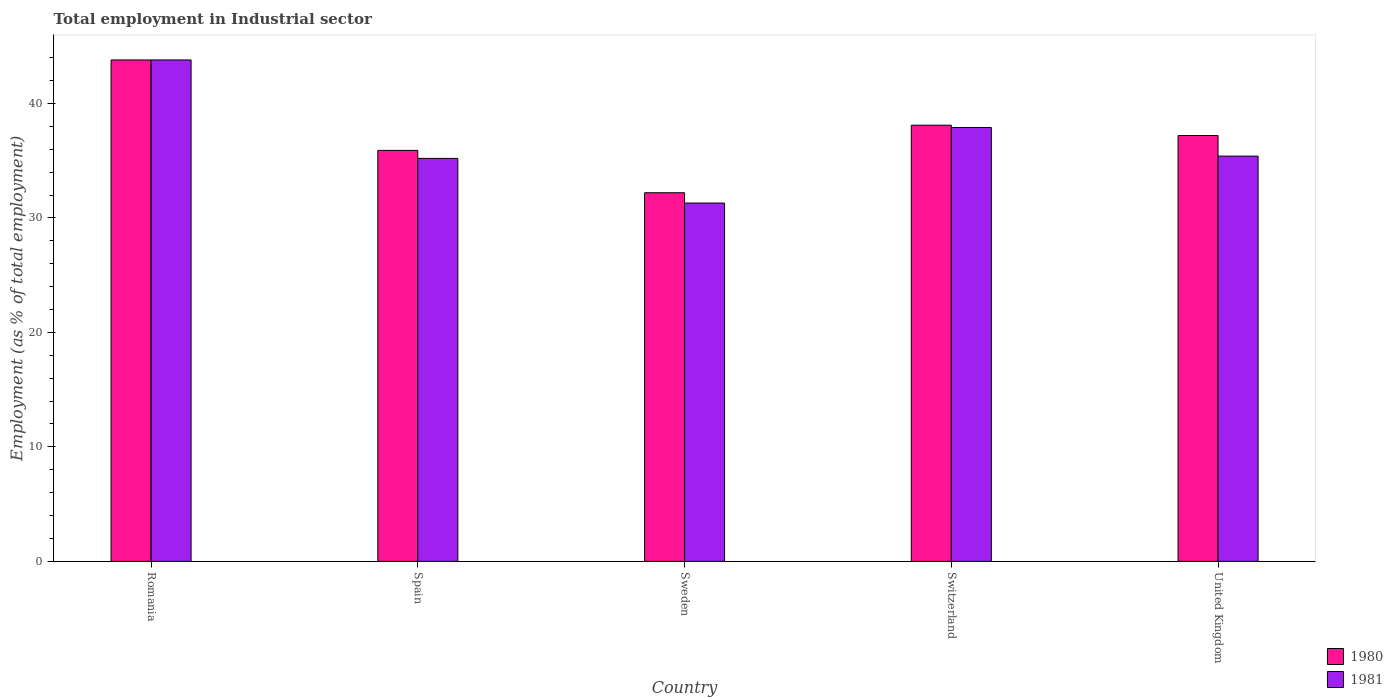Are the number of bars on each tick of the X-axis equal?
Your answer should be very brief. Yes. How many bars are there on the 1st tick from the left?
Make the answer very short. 2. How many bars are there on the 4th tick from the right?
Make the answer very short. 2. What is the label of the 4th group of bars from the left?
Offer a very short reply. Switzerland. What is the employment in industrial sector in 1981 in Sweden?
Ensure brevity in your answer.  31.3. Across all countries, what is the maximum employment in industrial sector in 1981?
Your response must be concise. 43.8. Across all countries, what is the minimum employment in industrial sector in 1980?
Offer a very short reply. 32.2. In which country was the employment in industrial sector in 1980 maximum?
Offer a very short reply. Romania. In which country was the employment in industrial sector in 1981 minimum?
Keep it short and to the point. Sweden. What is the total employment in industrial sector in 1981 in the graph?
Give a very brief answer. 183.6. What is the difference between the employment in industrial sector in 1980 in Spain and that in Sweden?
Your answer should be compact. 3.7. What is the difference between the employment in industrial sector in 1980 in United Kingdom and the employment in industrial sector in 1981 in Spain?
Keep it short and to the point. 2. What is the average employment in industrial sector in 1981 per country?
Offer a very short reply. 36.72. What is the difference between the employment in industrial sector of/in 1980 and employment in industrial sector of/in 1981 in Spain?
Provide a short and direct response. 0.7. In how many countries, is the employment in industrial sector in 1980 greater than 24 %?
Your answer should be very brief. 5. What is the ratio of the employment in industrial sector in 1981 in Spain to that in Switzerland?
Make the answer very short. 0.93. Is the difference between the employment in industrial sector in 1980 in Romania and Switzerland greater than the difference between the employment in industrial sector in 1981 in Romania and Switzerland?
Provide a short and direct response. No. What is the difference between the highest and the second highest employment in industrial sector in 1980?
Your answer should be compact. 6.6. What is the difference between the highest and the lowest employment in industrial sector in 1981?
Ensure brevity in your answer.  12.5. Is the sum of the employment in industrial sector in 1981 in Romania and Sweden greater than the maximum employment in industrial sector in 1980 across all countries?
Ensure brevity in your answer.  Yes. Are all the bars in the graph horizontal?
Offer a terse response. No. What is the difference between two consecutive major ticks on the Y-axis?
Your answer should be compact. 10. How many legend labels are there?
Keep it short and to the point. 2. How are the legend labels stacked?
Keep it short and to the point. Vertical. What is the title of the graph?
Make the answer very short. Total employment in Industrial sector. Does "1981" appear as one of the legend labels in the graph?
Offer a very short reply. Yes. What is the label or title of the Y-axis?
Your answer should be very brief. Employment (as % of total employment). What is the Employment (as % of total employment) of 1980 in Romania?
Provide a short and direct response. 43.8. What is the Employment (as % of total employment) in 1981 in Romania?
Provide a short and direct response. 43.8. What is the Employment (as % of total employment) of 1980 in Spain?
Offer a terse response. 35.9. What is the Employment (as % of total employment) in 1981 in Spain?
Provide a short and direct response. 35.2. What is the Employment (as % of total employment) in 1980 in Sweden?
Offer a terse response. 32.2. What is the Employment (as % of total employment) in 1981 in Sweden?
Keep it short and to the point. 31.3. What is the Employment (as % of total employment) of 1980 in Switzerland?
Ensure brevity in your answer.  38.1. What is the Employment (as % of total employment) in 1981 in Switzerland?
Offer a very short reply. 37.9. What is the Employment (as % of total employment) of 1980 in United Kingdom?
Provide a succinct answer. 37.2. What is the Employment (as % of total employment) in 1981 in United Kingdom?
Make the answer very short. 35.4. Across all countries, what is the maximum Employment (as % of total employment) in 1980?
Give a very brief answer. 43.8. Across all countries, what is the maximum Employment (as % of total employment) of 1981?
Provide a short and direct response. 43.8. Across all countries, what is the minimum Employment (as % of total employment) in 1980?
Offer a very short reply. 32.2. Across all countries, what is the minimum Employment (as % of total employment) of 1981?
Provide a short and direct response. 31.3. What is the total Employment (as % of total employment) of 1980 in the graph?
Your response must be concise. 187.2. What is the total Employment (as % of total employment) of 1981 in the graph?
Offer a very short reply. 183.6. What is the difference between the Employment (as % of total employment) of 1980 in Romania and that in Spain?
Provide a short and direct response. 7.9. What is the difference between the Employment (as % of total employment) of 1981 in Romania and that in Spain?
Offer a terse response. 8.6. What is the difference between the Employment (as % of total employment) in 1980 in Romania and that in Switzerland?
Give a very brief answer. 5.7. What is the difference between the Employment (as % of total employment) in 1981 in Romania and that in Switzerland?
Make the answer very short. 5.9. What is the difference between the Employment (as % of total employment) of 1980 in Spain and that in Sweden?
Make the answer very short. 3.7. What is the difference between the Employment (as % of total employment) of 1980 in Spain and that in Switzerland?
Provide a short and direct response. -2.2. What is the difference between the Employment (as % of total employment) of 1980 in Sweden and that in United Kingdom?
Give a very brief answer. -5. What is the difference between the Employment (as % of total employment) in 1980 in Switzerland and that in United Kingdom?
Make the answer very short. 0.9. What is the difference between the Employment (as % of total employment) in 1981 in Switzerland and that in United Kingdom?
Your answer should be very brief. 2.5. What is the difference between the Employment (as % of total employment) in 1980 in Romania and the Employment (as % of total employment) in 1981 in Spain?
Your response must be concise. 8.6. What is the difference between the Employment (as % of total employment) of 1980 in Romania and the Employment (as % of total employment) of 1981 in Switzerland?
Provide a succinct answer. 5.9. What is the difference between the Employment (as % of total employment) in 1980 in Romania and the Employment (as % of total employment) in 1981 in United Kingdom?
Make the answer very short. 8.4. What is the difference between the Employment (as % of total employment) of 1980 in Sweden and the Employment (as % of total employment) of 1981 in United Kingdom?
Offer a terse response. -3.2. What is the average Employment (as % of total employment) in 1980 per country?
Offer a terse response. 37.44. What is the average Employment (as % of total employment) of 1981 per country?
Offer a terse response. 36.72. What is the difference between the Employment (as % of total employment) of 1980 and Employment (as % of total employment) of 1981 in Spain?
Keep it short and to the point. 0.7. What is the difference between the Employment (as % of total employment) in 1980 and Employment (as % of total employment) in 1981 in Sweden?
Ensure brevity in your answer.  0.9. What is the difference between the Employment (as % of total employment) of 1980 and Employment (as % of total employment) of 1981 in United Kingdom?
Keep it short and to the point. 1.8. What is the ratio of the Employment (as % of total employment) in 1980 in Romania to that in Spain?
Give a very brief answer. 1.22. What is the ratio of the Employment (as % of total employment) of 1981 in Romania to that in Spain?
Offer a terse response. 1.24. What is the ratio of the Employment (as % of total employment) in 1980 in Romania to that in Sweden?
Ensure brevity in your answer.  1.36. What is the ratio of the Employment (as % of total employment) of 1981 in Romania to that in Sweden?
Give a very brief answer. 1.4. What is the ratio of the Employment (as % of total employment) of 1980 in Romania to that in Switzerland?
Offer a terse response. 1.15. What is the ratio of the Employment (as % of total employment) of 1981 in Romania to that in Switzerland?
Your answer should be compact. 1.16. What is the ratio of the Employment (as % of total employment) of 1980 in Romania to that in United Kingdom?
Provide a short and direct response. 1.18. What is the ratio of the Employment (as % of total employment) in 1981 in Romania to that in United Kingdom?
Ensure brevity in your answer.  1.24. What is the ratio of the Employment (as % of total employment) in 1980 in Spain to that in Sweden?
Ensure brevity in your answer.  1.11. What is the ratio of the Employment (as % of total employment) in 1981 in Spain to that in Sweden?
Make the answer very short. 1.12. What is the ratio of the Employment (as % of total employment) in 1980 in Spain to that in Switzerland?
Provide a short and direct response. 0.94. What is the ratio of the Employment (as % of total employment) of 1981 in Spain to that in Switzerland?
Your answer should be compact. 0.93. What is the ratio of the Employment (as % of total employment) of 1980 in Spain to that in United Kingdom?
Your response must be concise. 0.97. What is the ratio of the Employment (as % of total employment) of 1980 in Sweden to that in Switzerland?
Offer a terse response. 0.85. What is the ratio of the Employment (as % of total employment) of 1981 in Sweden to that in Switzerland?
Offer a very short reply. 0.83. What is the ratio of the Employment (as % of total employment) in 1980 in Sweden to that in United Kingdom?
Keep it short and to the point. 0.87. What is the ratio of the Employment (as % of total employment) in 1981 in Sweden to that in United Kingdom?
Your answer should be compact. 0.88. What is the ratio of the Employment (as % of total employment) of 1980 in Switzerland to that in United Kingdom?
Your response must be concise. 1.02. What is the ratio of the Employment (as % of total employment) of 1981 in Switzerland to that in United Kingdom?
Your answer should be compact. 1.07. What is the difference between the highest and the second highest Employment (as % of total employment) in 1980?
Ensure brevity in your answer.  5.7. What is the difference between the highest and the second highest Employment (as % of total employment) in 1981?
Offer a very short reply. 5.9. What is the difference between the highest and the lowest Employment (as % of total employment) of 1981?
Keep it short and to the point. 12.5. 